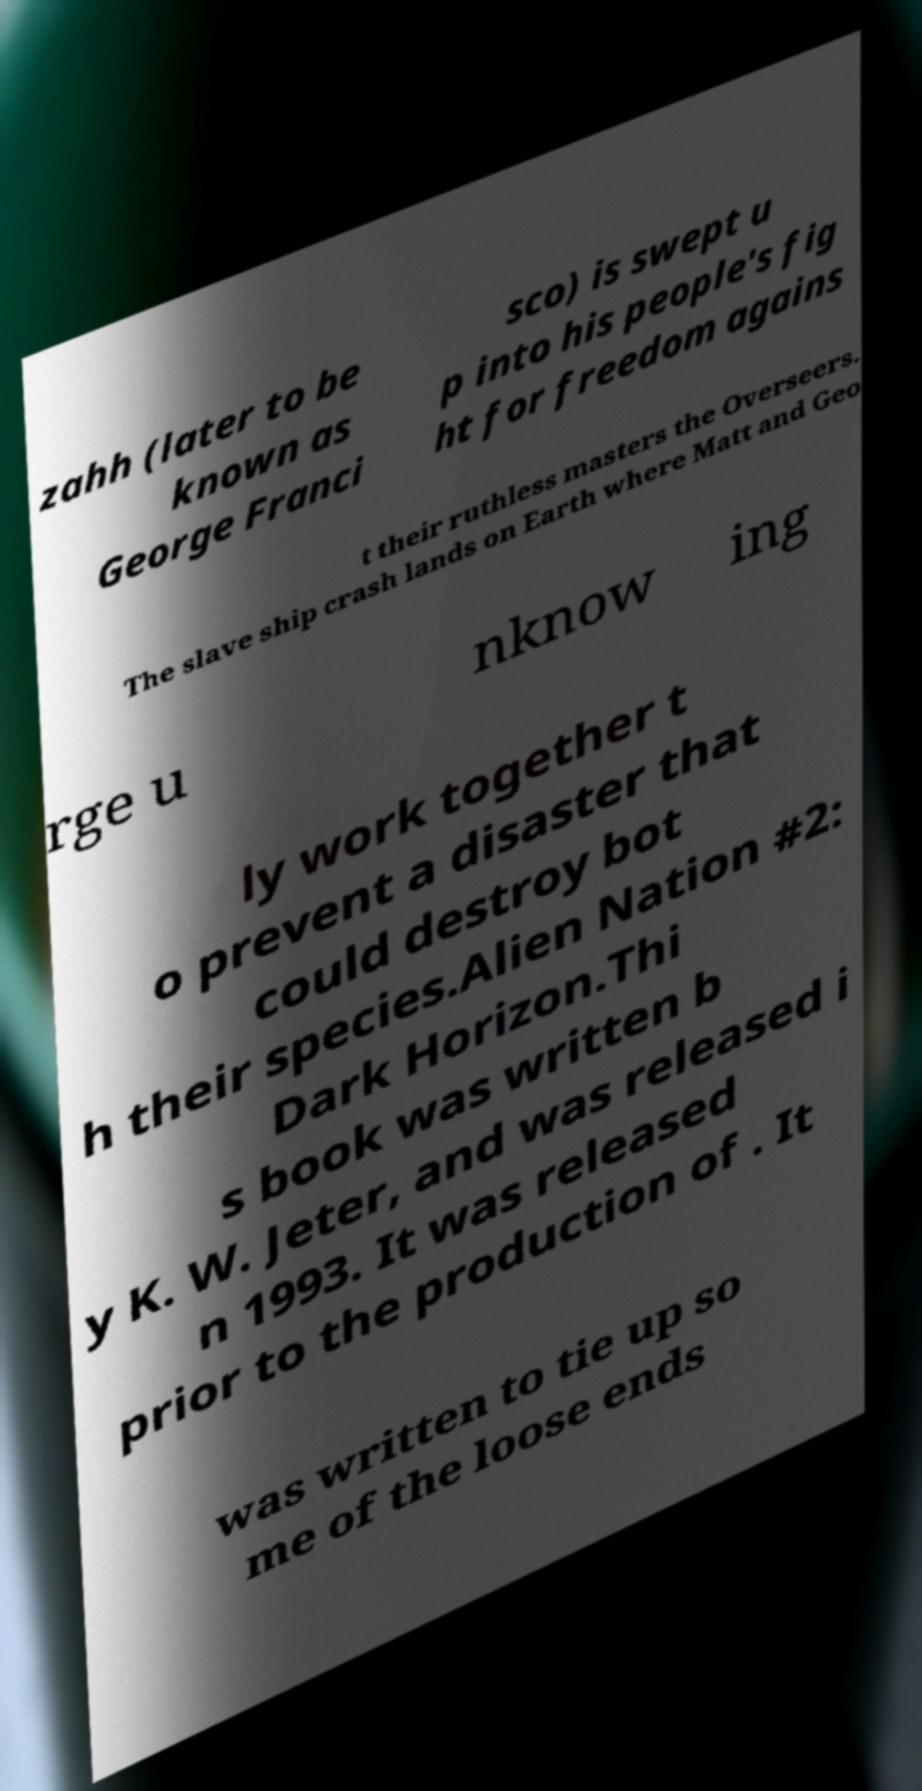Can you accurately transcribe the text from the provided image for me? zahh (later to be known as George Franci sco) is swept u p into his people's fig ht for freedom agains t their ruthless masters the Overseers. The slave ship crash lands on Earth where Matt and Geo rge u nknow ing ly work together t o prevent a disaster that could destroy bot h their species.Alien Nation #2: Dark Horizon.Thi s book was written b y K. W. Jeter, and was released i n 1993. It was released prior to the production of . It was written to tie up so me of the loose ends 